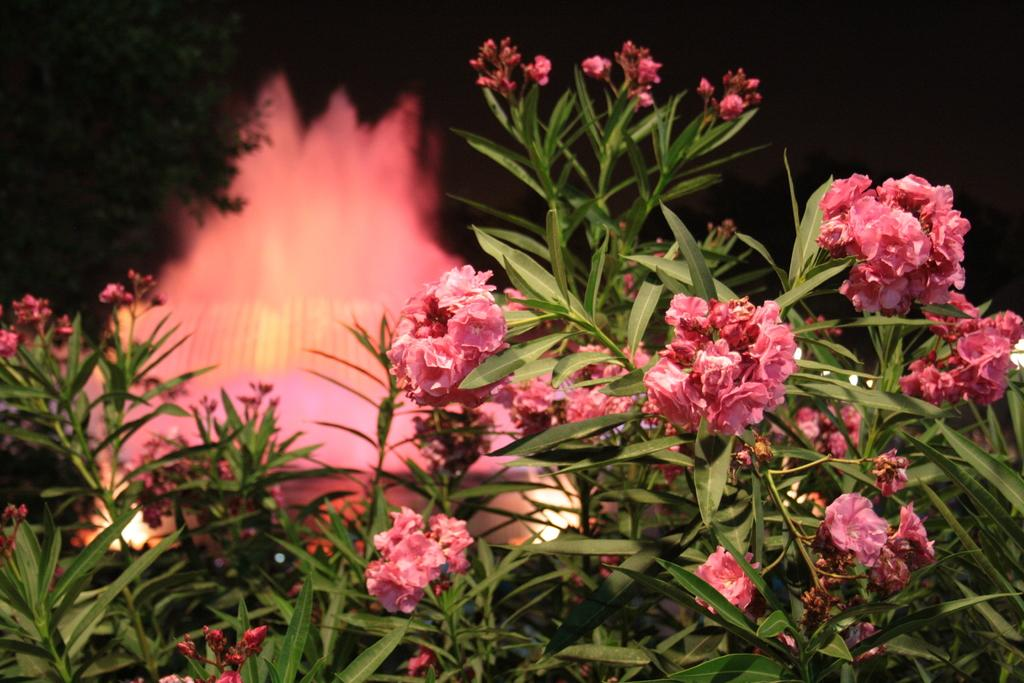What types of vegetation can be seen in the foreground of the image? There are flowers and plants in the foreground of the image. What might be present in the background of the image? There might be a fountain in the background of the image. What other natural elements can be seen in the background of the image? There are trees in the background of the image. How does the pollution affect the flowers and plants in the image? There is no indication of pollution in the image, so its effect on the flowers and plants cannot be determined. 